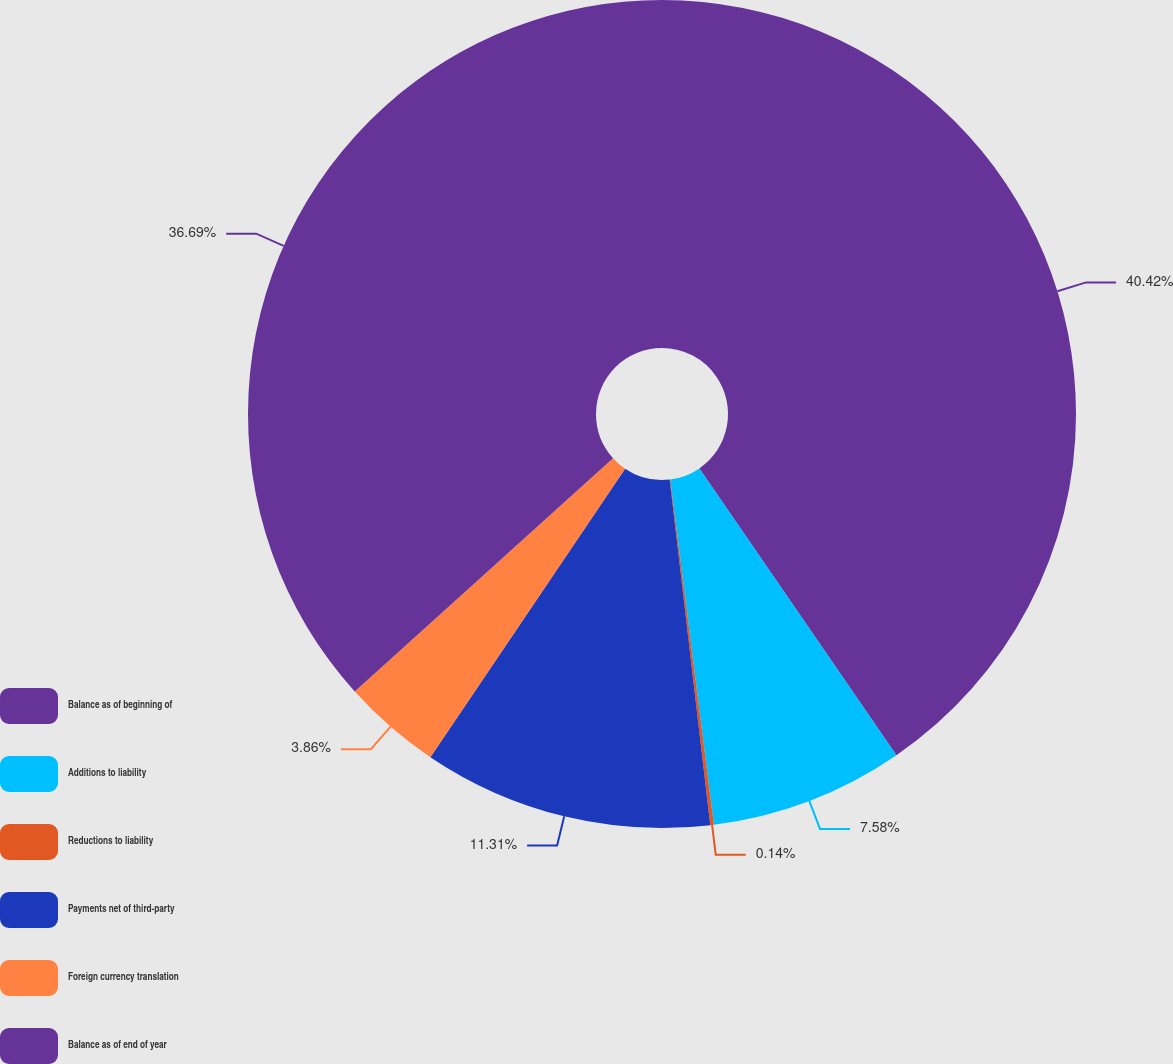<chart> <loc_0><loc_0><loc_500><loc_500><pie_chart><fcel>Balance as of beginning of<fcel>Additions to liability<fcel>Reductions to liability<fcel>Payments net of third-party<fcel>Foreign currency translation<fcel>Balance as of end of year<nl><fcel>40.42%<fcel>7.58%<fcel>0.14%<fcel>11.31%<fcel>3.86%<fcel>36.69%<nl></chart> 